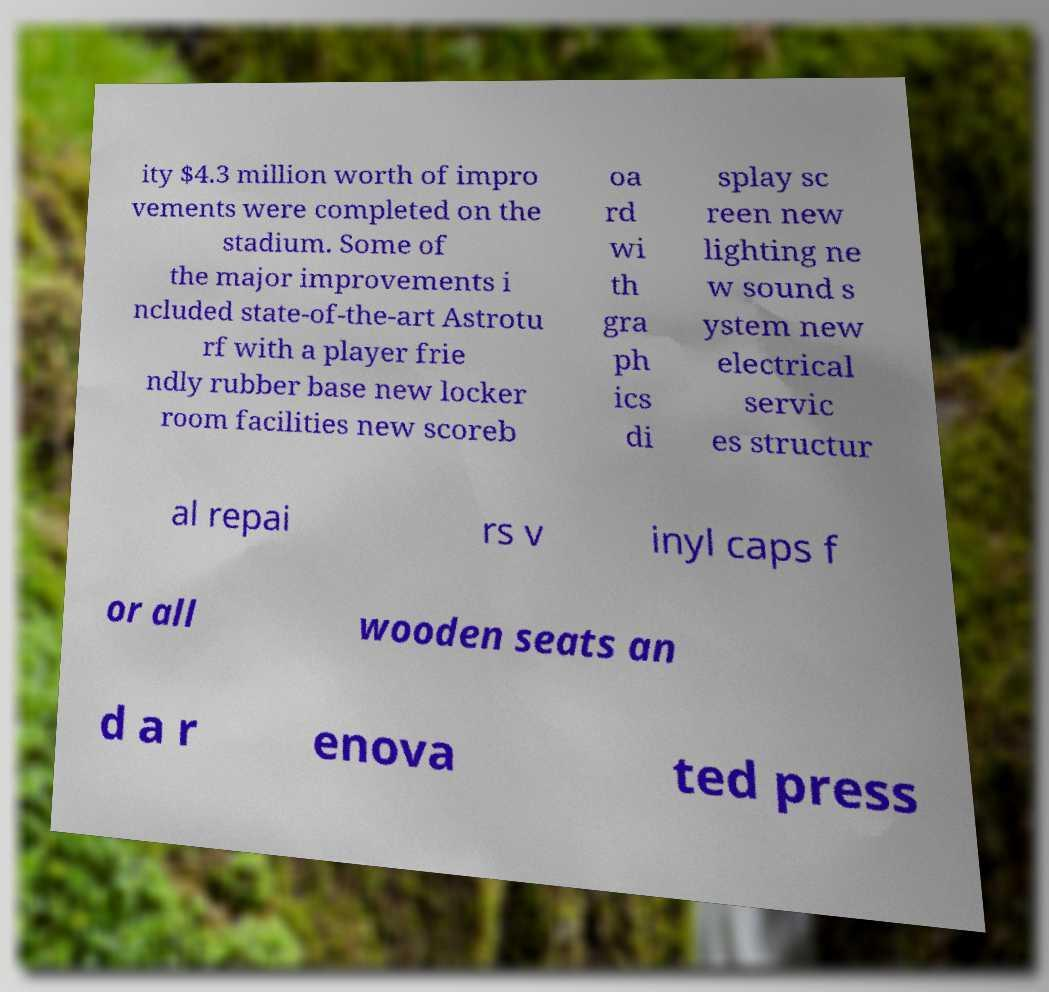Can you read and provide the text displayed in the image?This photo seems to have some interesting text. Can you extract and type it out for me? ity $4.3 million worth of impro vements were completed on the stadium. Some of the major improvements i ncluded state-of-the-art Astrotu rf with a player frie ndly rubber base new locker room facilities new scoreb oa rd wi th gra ph ics di splay sc reen new lighting ne w sound s ystem new electrical servic es structur al repai rs v inyl caps f or all wooden seats an d a r enova ted press 